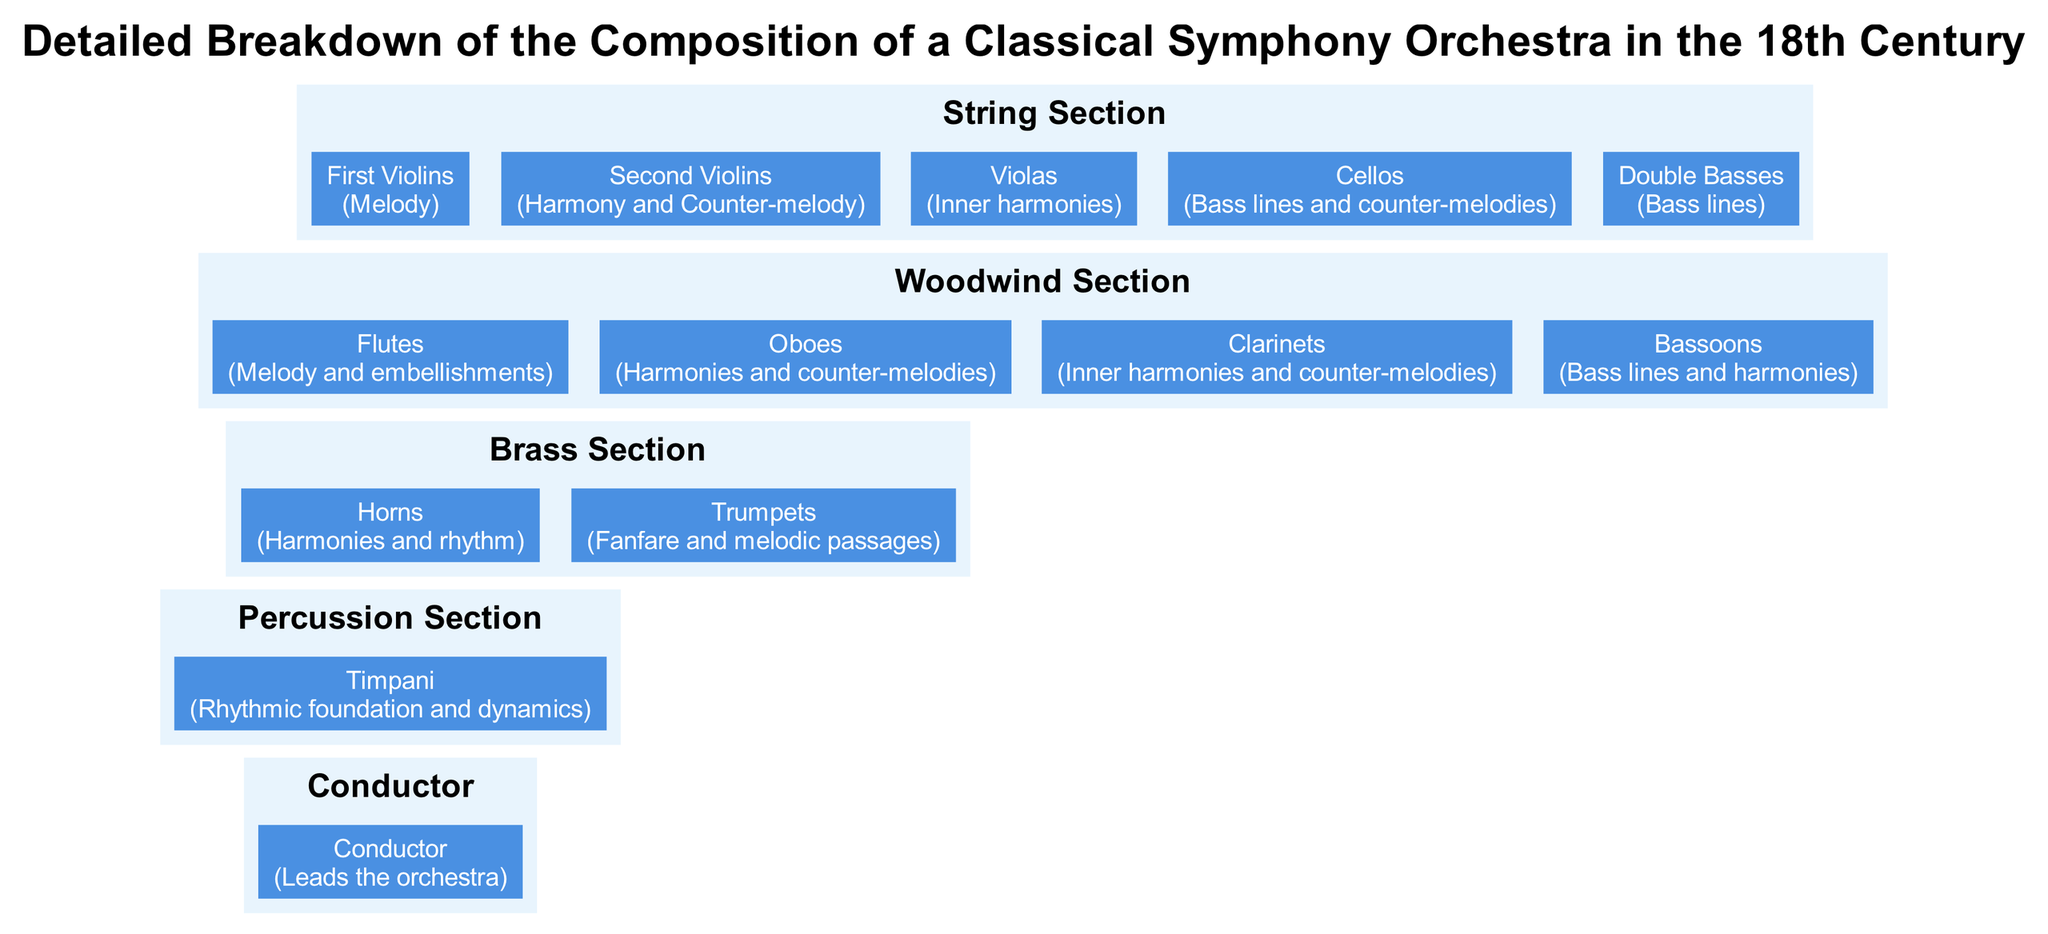What is the role of the First Violins? According to the diagram, the First Violins are assigned the role of producing Melody. This can be identified by locating the First Violins node and checking the text that describes their function.
Answer: Melody How many instruments are in the Brass Section? The Brass Section is represented by two instruments, which are the Horns and Trumpets. By counting the number of nodes listed under this section, we find there are two.
Answer: 2 What section does the Timpani belong to? The diagram clearly indicates that Timpani is part of the Percussion Section. This can be determined by locating the Timpani node and observing its placement within the corresponding section.
Answer: Percussion Section What are the roles assigned to the Woodwind Section instruments? The Woodwind Section consists of Flutes (Melody and embellishments), Oboes (Harmonies and counter-melodies), Clarinets (Inner harmonies and counter-melodies), and Bassoons (Bass lines and harmonies). Each node in this section details the respective roles of the instruments.
Answer: Melody and embellishments, Harmonies and counter-melodies, Inner harmonies and counter-melodies, Bass lines and harmonies Which section leads the orchestra? In the diagram, the Conductor is explicitly noted as the figure that leads the orchestra. By locating the Conductor node, we identify its unique role as the leader of the entire musical ensemble.
Answer: Conductor What instrument provides the rhythmic foundation in the orchestra? The Timpani is shown in the diagram as providing the rhythmic foundation and dynamics. This role is explicitly stated next to the Timpani node in the Percussion Section.
Answer: Timpani Which instrument in the String Section contributes to bass lines? According to the diagram, both the Cellos and Double Basses are involved in contributing to bass lines. The roles assigned to these instruments can be noted directly beneath their respective nodes.
Answer: Cellos and Double Basses How many sections are there in the orchestra diagram? The diagram contains five distinct sections: String Section, Woodwind Section, Brass Section, Percussion Section, and Conductor. By counting the labeled sections, we find a total of five.
Answer: 5 